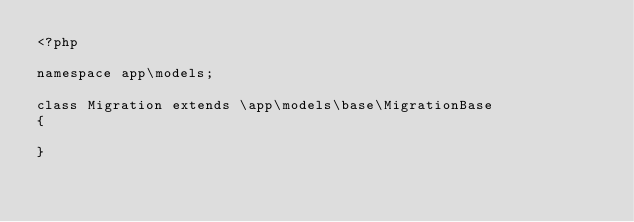<code> <loc_0><loc_0><loc_500><loc_500><_PHP_><?php

namespace app\models;

class Migration extends \app\models\base\MigrationBase
{
    
}</code> 